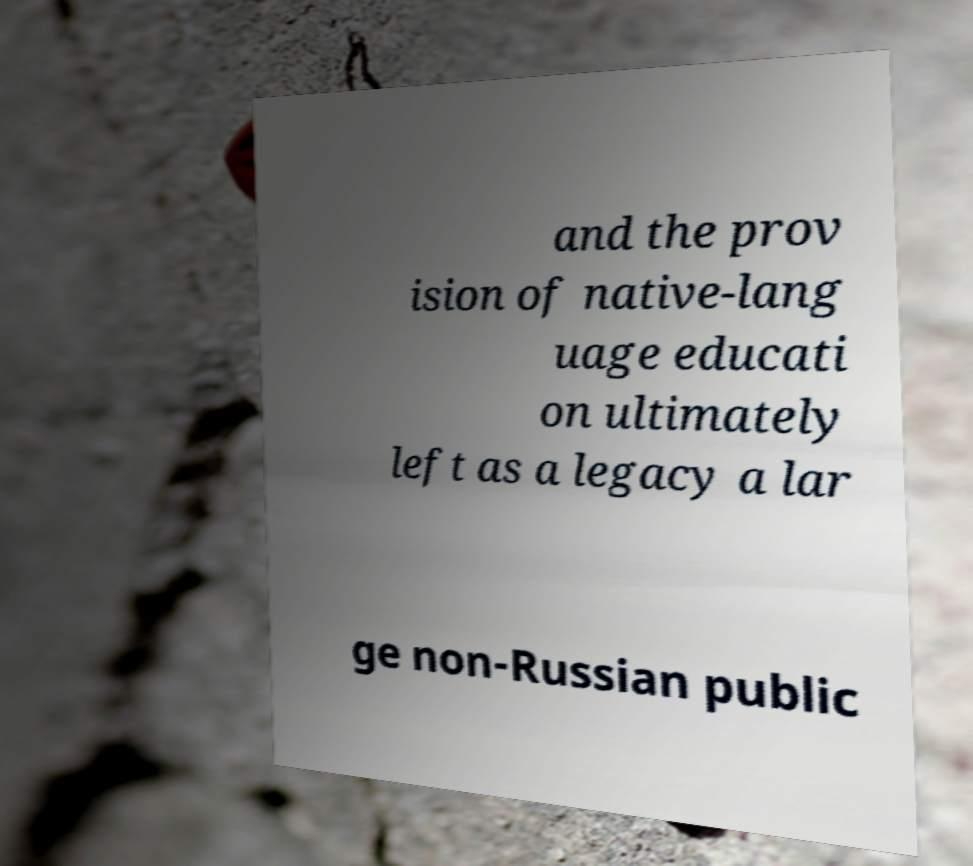What messages or text are displayed in this image? I need them in a readable, typed format. and the prov ision of native-lang uage educati on ultimately left as a legacy a lar ge non-Russian public 